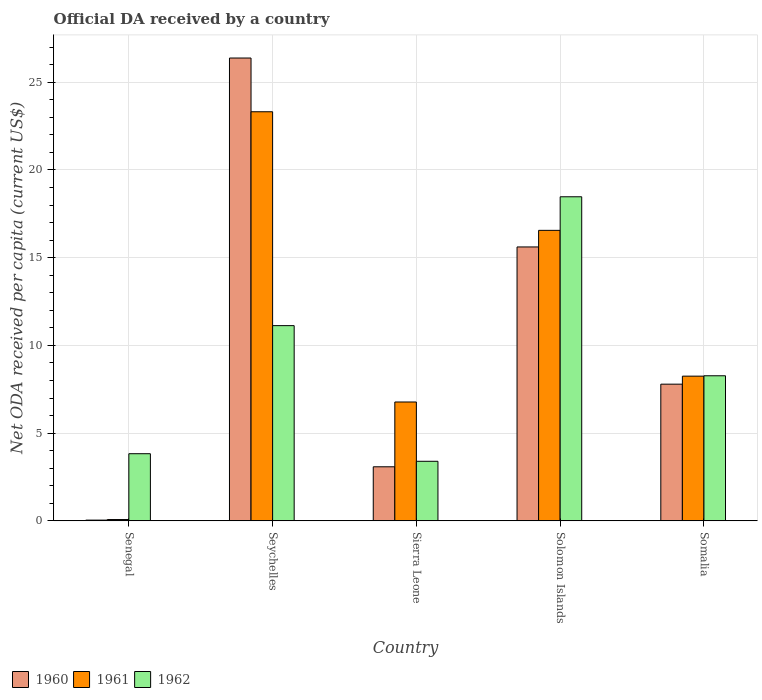What is the label of the 1st group of bars from the left?
Your answer should be very brief. Senegal. In how many cases, is the number of bars for a given country not equal to the number of legend labels?
Keep it short and to the point. 0. What is the ODA received in in 1961 in Seychelles?
Your answer should be compact. 23.32. Across all countries, what is the maximum ODA received in in 1960?
Your answer should be compact. 26.38. Across all countries, what is the minimum ODA received in in 1960?
Offer a terse response. 0.04. In which country was the ODA received in in 1960 maximum?
Provide a succinct answer. Seychelles. In which country was the ODA received in in 1961 minimum?
Your response must be concise. Senegal. What is the total ODA received in in 1961 in the graph?
Offer a very short reply. 54.97. What is the difference between the ODA received in in 1962 in Solomon Islands and that in Somalia?
Provide a short and direct response. 10.2. What is the difference between the ODA received in in 1960 in Senegal and the ODA received in in 1962 in Solomon Islands?
Offer a very short reply. -18.43. What is the average ODA received in in 1962 per country?
Give a very brief answer. 9.02. What is the difference between the ODA received in of/in 1960 and ODA received in of/in 1961 in Solomon Islands?
Provide a short and direct response. -0.95. In how many countries, is the ODA received in in 1962 greater than 17 US$?
Keep it short and to the point. 1. What is the ratio of the ODA received in in 1960 in Senegal to that in Solomon Islands?
Your response must be concise. 0. Is the ODA received in in 1961 in Senegal less than that in Seychelles?
Provide a succinct answer. Yes. Is the difference between the ODA received in in 1960 in Sierra Leone and Somalia greater than the difference between the ODA received in in 1961 in Sierra Leone and Somalia?
Provide a succinct answer. No. What is the difference between the highest and the second highest ODA received in in 1961?
Give a very brief answer. 8.31. What is the difference between the highest and the lowest ODA received in in 1961?
Offer a terse response. 23.24. In how many countries, is the ODA received in in 1961 greater than the average ODA received in in 1961 taken over all countries?
Make the answer very short. 2. Is the sum of the ODA received in in 1960 in Seychelles and Somalia greater than the maximum ODA received in in 1962 across all countries?
Provide a short and direct response. Yes. What does the 1st bar from the left in Senegal represents?
Offer a very short reply. 1960. What does the 2nd bar from the right in Seychelles represents?
Provide a short and direct response. 1961. Is it the case that in every country, the sum of the ODA received in in 1962 and ODA received in in 1960 is greater than the ODA received in in 1961?
Keep it short and to the point. No. How many bars are there?
Your answer should be compact. 15. Are all the bars in the graph horizontal?
Make the answer very short. No. Are the values on the major ticks of Y-axis written in scientific E-notation?
Your answer should be compact. No. Does the graph contain any zero values?
Provide a short and direct response. No. Where does the legend appear in the graph?
Offer a terse response. Bottom left. What is the title of the graph?
Make the answer very short. Official DA received by a country. What is the label or title of the Y-axis?
Your answer should be compact. Net ODA received per capita (current US$). What is the Net ODA received per capita (current US$) in 1960 in Senegal?
Offer a terse response. 0.04. What is the Net ODA received per capita (current US$) of 1961 in Senegal?
Provide a short and direct response. 0.07. What is the Net ODA received per capita (current US$) of 1962 in Senegal?
Your answer should be very brief. 3.83. What is the Net ODA received per capita (current US$) of 1960 in Seychelles?
Your answer should be very brief. 26.38. What is the Net ODA received per capita (current US$) in 1961 in Seychelles?
Provide a short and direct response. 23.32. What is the Net ODA received per capita (current US$) of 1962 in Seychelles?
Your answer should be compact. 11.13. What is the Net ODA received per capita (current US$) of 1960 in Sierra Leone?
Offer a terse response. 3.08. What is the Net ODA received per capita (current US$) in 1961 in Sierra Leone?
Ensure brevity in your answer.  6.77. What is the Net ODA received per capita (current US$) of 1962 in Sierra Leone?
Your answer should be very brief. 3.39. What is the Net ODA received per capita (current US$) in 1960 in Solomon Islands?
Make the answer very short. 15.61. What is the Net ODA received per capita (current US$) in 1961 in Solomon Islands?
Your answer should be compact. 16.56. What is the Net ODA received per capita (current US$) in 1962 in Solomon Islands?
Your answer should be very brief. 18.47. What is the Net ODA received per capita (current US$) in 1960 in Somalia?
Your response must be concise. 7.79. What is the Net ODA received per capita (current US$) of 1961 in Somalia?
Offer a very short reply. 8.25. What is the Net ODA received per capita (current US$) in 1962 in Somalia?
Provide a short and direct response. 8.27. Across all countries, what is the maximum Net ODA received per capita (current US$) in 1960?
Ensure brevity in your answer.  26.38. Across all countries, what is the maximum Net ODA received per capita (current US$) of 1961?
Provide a succinct answer. 23.32. Across all countries, what is the maximum Net ODA received per capita (current US$) in 1962?
Give a very brief answer. 18.47. Across all countries, what is the minimum Net ODA received per capita (current US$) in 1960?
Keep it short and to the point. 0.04. Across all countries, what is the minimum Net ODA received per capita (current US$) of 1961?
Your answer should be compact. 0.07. Across all countries, what is the minimum Net ODA received per capita (current US$) in 1962?
Your answer should be compact. 3.39. What is the total Net ODA received per capita (current US$) in 1960 in the graph?
Offer a very short reply. 52.9. What is the total Net ODA received per capita (current US$) in 1961 in the graph?
Provide a succinct answer. 54.97. What is the total Net ODA received per capita (current US$) of 1962 in the graph?
Offer a very short reply. 45.08. What is the difference between the Net ODA received per capita (current US$) in 1960 in Senegal and that in Seychelles?
Keep it short and to the point. -26.34. What is the difference between the Net ODA received per capita (current US$) of 1961 in Senegal and that in Seychelles?
Give a very brief answer. -23.24. What is the difference between the Net ODA received per capita (current US$) of 1962 in Senegal and that in Seychelles?
Give a very brief answer. -7.3. What is the difference between the Net ODA received per capita (current US$) of 1960 in Senegal and that in Sierra Leone?
Your response must be concise. -3.04. What is the difference between the Net ODA received per capita (current US$) in 1961 in Senegal and that in Sierra Leone?
Make the answer very short. -6.7. What is the difference between the Net ODA received per capita (current US$) of 1962 in Senegal and that in Sierra Leone?
Your response must be concise. 0.43. What is the difference between the Net ODA received per capita (current US$) in 1960 in Senegal and that in Solomon Islands?
Offer a terse response. -15.57. What is the difference between the Net ODA received per capita (current US$) in 1961 in Senegal and that in Solomon Islands?
Your answer should be compact. -16.48. What is the difference between the Net ODA received per capita (current US$) of 1962 in Senegal and that in Solomon Islands?
Your response must be concise. -14.64. What is the difference between the Net ODA received per capita (current US$) of 1960 in Senegal and that in Somalia?
Ensure brevity in your answer.  -7.75. What is the difference between the Net ODA received per capita (current US$) in 1961 in Senegal and that in Somalia?
Provide a succinct answer. -8.17. What is the difference between the Net ODA received per capita (current US$) of 1962 in Senegal and that in Somalia?
Provide a succinct answer. -4.44. What is the difference between the Net ODA received per capita (current US$) in 1960 in Seychelles and that in Sierra Leone?
Offer a terse response. 23.3. What is the difference between the Net ODA received per capita (current US$) of 1961 in Seychelles and that in Sierra Leone?
Offer a very short reply. 16.54. What is the difference between the Net ODA received per capita (current US$) in 1962 in Seychelles and that in Sierra Leone?
Provide a succinct answer. 7.73. What is the difference between the Net ODA received per capita (current US$) of 1960 in Seychelles and that in Solomon Islands?
Provide a short and direct response. 10.77. What is the difference between the Net ODA received per capita (current US$) in 1961 in Seychelles and that in Solomon Islands?
Your answer should be very brief. 6.76. What is the difference between the Net ODA received per capita (current US$) in 1962 in Seychelles and that in Solomon Islands?
Give a very brief answer. -7.34. What is the difference between the Net ODA received per capita (current US$) of 1960 in Seychelles and that in Somalia?
Provide a short and direct response. 18.59. What is the difference between the Net ODA received per capita (current US$) in 1961 in Seychelles and that in Somalia?
Keep it short and to the point. 15.07. What is the difference between the Net ODA received per capita (current US$) of 1962 in Seychelles and that in Somalia?
Your answer should be very brief. 2.86. What is the difference between the Net ODA received per capita (current US$) in 1960 in Sierra Leone and that in Solomon Islands?
Offer a very short reply. -12.53. What is the difference between the Net ODA received per capita (current US$) of 1961 in Sierra Leone and that in Solomon Islands?
Make the answer very short. -9.78. What is the difference between the Net ODA received per capita (current US$) of 1962 in Sierra Leone and that in Solomon Islands?
Your answer should be compact. -15.08. What is the difference between the Net ODA received per capita (current US$) in 1960 in Sierra Leone and that in Somalia?
Offer a very short reply. -4.71. What is the difference between the Net ODA received per capita (current US$) of 1961 in Sierra Leone and that in Somalia?
Offer a terse response. -1.47. What is the difference between the Net ODA received per capita (current US$) in 1962 in Sierra Leone and that in Somalia?
Give a very brief answer. -4.87. What is the difference between the Net ODA received per capita (current US$) of 1960 in Solomon Islands and that in Somalia?
Give a very brief answer. 7.82. What is the difference between the Net ODA received per capita (current US$) of 1961 in Solomon Islands and that in Somalia?
Ensure brevity in your answer.  8.31. What is the difference between the Net ODA received per capita (current US$) of 1962 in Solomon Islands and that in Somalia?
Your response must be concise. 10.2. What is the difference between the Net ODA received per capita (current US$) in 1960 in Senegal and the Net ODA received per capita (current US$) in 1961 in Seychelles?
Keep it short and to the point. -23.28. What is the difference between the Net ODA received per capita (current US$) in 1960 in Senegal and the Net ODA received per capita (current US$) in 1962 in Seychelles?
Provide a short and direct response. -11.08. What is the difference between the Net ODA received per capita (current US$) of 1961 in Senegal and the Net ODA received per capita (current US$) of 1962 in Seychelles?
Make the answer very short. -11.05. What is the difference between the Net ODA received per capita (current US$) in 1960 in Senegal and the Net ODA received per capita (current US$) in 1961 in Sierra Leone?
Provide a succinct answer. -6.73. What is the difference between the Net ODA received per capita (current US$) in 1960 in Senegal and the Net ODA received per capita (current US$) in 1962 in Sierra Leone?
Your answer should be compact. -3.35. What is the difference between the Net ODA received per capita (current US$) in 1961 in Senegal and the Net ODA received per capita (current US$) in 1962 in Sierra Leone?
Provide a short and direct response. -3.32. What is the difference between the Net ODA received per capita (current US$) in 1960 in Senegal and the Net ODA received per capita (current US$) in 1961 in Solomon Islands?
Provide a short and direct response. -16.52. What is the difference between the Net ODA received per capita (current US$) in 1960 in Senegal and the Net ODA received per capita (current US$) in 1962 in Solomon Islands?
Ensure brevity in your answer.  -18.43. What is the difference between the Net ODA received per capita (current US$) of 1961 in Senegal and the Net ODA received per capita (current US$) of 1962 in Solomon Islands?
Offer a terse response. -18.4. What is the difference between the Net ODA received per capita (current US$) of 1960 in Senegal and the Net ODA received per capita (current US$) of 1961 in Somalia?
Make the answer very short. -8.21. What is the difference between the Net ODA received per capita (current US$) of 1960 in Senegal and the Net ODA received per capita (current US$) of 1962 in Somalia?
Give a very brief answer. -8.23. What is the difference between the Net ODA received per capita (current US$) of 1961 in Senegal and the Net ODA received per capita (current US$) of 1962 in Somalia?
Make the answer very short. -8.19. What is the difference between the Net ODA received per capita (current US$) in 1960 in Seychelles and the Net ODA received per capita (current US$) in 1961 in Sierra Leone?
Keep it short and to the point. 19.61. What is the difference between the Net ODA received per capita (current US$) in 1960 in Seychelles and the Net ODA received per capita (current US$) in 1962 in Sierra Leone?
Your answer should be compact. 22.99. What is the difference between the Net ODA received per capita (current US$) in 1961 in Seychelles and the Net ODA received per capita (current US$) in 1962 in Sierra Leone?
Provide a short and direct response. 19.92. What is the difference between the Net ODA received per capita (current US$) of 1960 in Seychelles and the Net ODA received per capita (current US$) of 1961 in Solomon Islands?
Offer a terse response. 9.82. What is the difference between the Net ODA received per capita (current US$) of 1960 in Seychelles and the Net ODA received per capita (current US$) of 1962 in Solomon Islands?
Give a very brief answer. 7.91. What is the difference between the Net ODA received per capita (current US$) of 1961 in Seychelles and the Net ODA received per capita (current US$) of 1962 in Solomon Islands?
Make the answer very short. 4.85. What is the difference between the Net ODA received per capita (current US$) of 1960 in Seychelles and the Net ODA received per capita (current US$) of 1961 in Somalia?
Your answer should be compact. 18.13. What is the difference between the Net ODA received per capita (current US$) of 1960 in Seychelles and the Net ODA received per capita (current US$) of 1962 in Somalia?
Your answer should be compact. 18.11. What is the difference between the Net ODA received per capita (current US$) of 1961 in Seychelles and the Net ODA received per capita (current US$) of 1962 in Somalia?
Your answer should be very brief. 15.05. What is the difference between the Net ODA received per capita (current US$) of 1960 in Sierra Leone and the Net ODA received per capita (current US$) of 1961 in Solomon Islands?
Offer a very short reply. -13.48. What is the difference between the Net ODA received per capita (current US$) in 1960 in Sierra Leone and the Net ODA received per capita (current US$) in 1962 in Solomon Islands?
Ensure brevity in your answer.  -15.39. What is the difference between the Net ODA received per capita (current US$) of 1961 in Sierra Leone and the Net ODA received per capita (current US$) of 1962 in Solomon Islands?
Your answer should be very brief. -11.7. What is the difference between the Net ODA received per capita (current US$) of 1960 in Sierra Leone and the Net ODA received per capita (current US$) of 1961 in Somalia?
Offer a very short reply. -5.17. What is the difference between the Net ODA received per capita (current US$) in 1960 in Sierra Leone and the Net ODA received per capita (current US$) in 1962 in Somalia?
Give a very brief answer. -5.19. What is the difference between the Net ODA received per capita (current US$) in 1961 in Sierra Leone and the Net ODA received per capita (current US$) in 1962 in Somalia?
Offer a very short reply. -1.49. What is the difference between the Net ODA received per capita (current US$) in 1960 in Solomon Islands and the Net ODA received per capita (current US$) in 1961 in Somalia?
Ensure brevity in your answer.  7.36. What is the difference between the Net ODA received per capita (current US$) in 1960 in Solomon Islands and the Net ODA received per capita (current US$) in 1962 in Somalia?
Keep it short and to the point. 7.34. What is the difference between the Net ODA received per capita (current US$) of 1961 in Solomon Islands and the Net ODA received per capita (current US$) of 1962 in Somalia?
Offer a very short reply. 8.29. What is the average Net ODA received per capita (current US$) in 1960 per country?
Provide a succinct answer. 10.58. What is the average Net ODA received per capita (current US$) in 1961 per country?
Your answer should be compact. 10.99. What is the average Net ODA received per capita (current US$) in 1962 per country?
Your response must be concise. 9.02. What is the difference between the Net ODA received per capita (current US$) in 1960 and Net ODA received per capita (current US$) in 1961 in Senegal?
Make the answer very short. -0.03. What is the difference between the Net ODA received per capita (current US$) of 1960 and Net ODA received per capita (current US$) of 1962 in Senegal?
Offer a terse response. -3.78. What is the difference between the Net ODA received per capita (current US$) in 1961 and Net ODA received per capita (current US$) in 1962 in Senegal?
Your answer should be compact. -3.75. What is the difference between the Net ODA received per capita (current US$) of 1960 and Net ODA received per capita (current US$) of 1961 in Seychelles?
Provide a succinct answer. 3.06. What is the difference between the Net ODA received per capita (current US$) in 1960 and Net ODA received per capita (current US$) in 1962 in Seychelles?
Your response must be concise. 15.25. What is the difference between the Net ODA received per capita (current US$) in 1961 and Net ODA received per capita (current US$) in 1962 in Seychelles?
Provide a succinct answer. 12.19. What is the difference between the Net ODA received per capita (current US$) in 1960 and Net ODA received per capita (current US$) in 1961 in Sierra Leone?
Your response must be concise. -3.69. What is the difference between the Net ODA received per capita (current US$) of 1960 and Net ODA received per capita (current US$) of 1962 in Sierra Leone?
Provide a succinct answer. -0.31. What is the difference between the Net ODA received per capita (current US$) in 1961 and Net ODA received per capita (current US$) in 1962 in Sierra Leone?
Your response must be concise. 3.38. What is the difference between the Net ODA received per capita (current US$) of 1960 and Net ODA received per capita (current US$) of 1961 in Solomon Islands?
Your answer should be compact. -0.95. What is the difference between the Net ODA received per capita (current US$) of 1960 and Net ODA received per capita (current US$) of 1962 in Solomon Islands?
Give a very brief answer. -2.86. What is the difference between the Net ODA received per capita (current US$) of 1961 and Net ODA received per capita (current US$) of 1962 in Solomon Islands?
Your answer should be very brief. -1.91. What is the difference between the Net ODA received per capita (current US$) in 1960 and Net ODA received per capita (current US$) in 1961 in Somalia?
Ensure brevity in your answer.  -0.46. What is the difference between the Net ODA received per capita (current US$) of 1960 and Net ODA received per capita (current US$) of 1962 in Somalia?
Your answer should be compact. -0.48. What is the difference between the Net ODA received per capita (current US$) of 1961 and Net ODA received per capita (current US$) of 1962 in Somalia?
Provide a succinct answer. -0.02. What is the ratio of the Net ODA received per capita (current US$) of 1960 in Senegal to that in Seychelles?
Offer a very short reply. 0. What is the ratio of the Net ODA received per capita (current US$) of 1961 in Senegal to that in Seychelles?
Keep it short and to the point. 0. What is the ratio of the Net ODA received per capita (current US$) of 1962 in Senegal to that in Seychelles?
Offer a very short reply. 0.34. What is the ratio of the Net ODA received per capita (current US$) of 1960 in Senegal to that in Sierra Leone?
Ensure brevity in your answer.  0.01. What is the ratio of the Net ODA received per capita (current US$) in 1961 in Senegal to that in Sierra Leone?
Provide a short and direct response. 0.01. What is the ratio of the Net ODA received per capita (current US$) of 1962 in Senegal to that in Sierra Leone?
Your response must be concise. 1.13. What is the ratio of the Net ODA received per capita (current US$) in 1960 in Senegal to that in Solomon Islands?
Your answer should be very brief. 0. What is the ratio of the Net ODA received per capita (current US$) of 1961 in Senegal to that in Solomon Islands?
Offer a terse response. 0. What is the ratio of the Net ODA received per capita (current US$) in 1962 in Senegal to that in Solomon Islands?
Offer a very short reply. 0.21. What is the ratio of the Net ODA received per capita (current US$) in 1960 in Senegal to that in Somalia?
Provide a short and direct response. 0.01. What is the ratio of the Net ODA received per capita (current US$) in 1961 in Senegal to that in Somalia?
Provide a short and direct response. 0.01. What is the ratio of the Net ODA received per capita (current US$) in 1962 in Senegal to that in Somalia?
Your response must be concise. 0.46. What is the ratio of the Net ODA received per capita (current US$) in 1960 in Seychelles to that in Sierra Leone?
Your answer should be compact. 8.56. What is the ratio of the Net ODA received per capita (current US$) in 1961 in Seychelles to that in Sierra Leone?
Make the answer very short. 3.44. What is the ratio of the Net ODA received per capita (current US$) in 1962 in Seychelles to that in Sierra Leone?
Provide a succinct answer. 3.28. What is the ratio of the Net ODA received per capita (current US$) in 1960 in Seychelles to that in Solomon Islands?
Ensure brevity in your answer.  1.69. What is the ratio of the Net ODA received per capita (current US$) of 1961 in Seychelles to that in Solomon Islands?
Your answer should be very brief. 1.41. What is the ratio of the Net ODA received per capita (current US$) of 1962 in Seychelles to that in Solomon Islands?
Make the answer very short. 0.6. What is the ratio of the Net ODA received per capita (current US$) in 1960 in Seychelles to that in Somalia?
Your response must be concise. 3.39. What is the ratio of the Net ODA received per capita (current US$) of 1961 in Seychelles to that in Somalia?
Give a very brief answer. 2.83. What is the ratio of the Net ODA received per capita (current US$) of 1962 in Seychelles to that in Somalia?
Give a very brief answer. 1.35. What is the ratio of the Net ODA received per capita (current US$) of 1960 in Sierra Leone to that in Solomon Islands?
Provide a short and direct response. 0.2. What is the ratio of the Net ODA received per capita (current US$) in 1961 in Sierra Leone to that in Solomon Islands?
Offer a terse response. 0.41. What is the ratio of the Net ODA received per capita (current US$) in 1962 in Sierra Leone to that in Solomon Islands?
Your response must be concise. 0.18. What is the ratio of the Net ODA received per capita (current US$) in 1960 in Sierra Leone to that in Somalia?
Give a very brief answer. 0.4. What is the ratio of the Net ODA received per capita (current US$) in 1961 in Sierra Leone to that in Somalia?
Your answer should be compact. 0.82. What is the ratio of the Net ODA received per capita (current US$) in 1962 in Sierra Leone to that in Somalia?
Make the answer very short. 0.41. What is the ratio of the Net ODA received per capita (current US$) in 1960 in Solomon Islands to that in Somalia?
Provide a short and direct response. 2. What is the ratio of the Net ODA received per capita (current US$) in 1961 in Solomon Islands to that in Somalia?
Your answer should be compact. 2.01. What is the ratio of the Net ODA received per capita (current US$) in 1962 in Solomon Islands to that in Somalia?
Keep it short and to the point. 2.23. What is the difference between the highest and the second highest Net ODA received per capita (current US$) in 1960?
Offer a very short reply. 10.77. What is the difference between the highest and the second highest Net ODA received per capita (current US$) in 1961?
Give a very brief answer. 6.76. What is the difference between the highest and the second highest Net ODA received per capita (current US$) in 1962?
Ensure brevity in your answer.  7.34. What is the difference between the highest and the lowest Net ODA received per capita (current US$) of 1960?
Your answer should be compact. 26.34. What is the difference between the highest and the lowest Net ODA received per capita (current US$) of 1961?
Make the answer very short. 23.24. What is the difference between the highest and the lowest Net ODA received per capita (current US$) in 1962?
Offer a terse response. 15.08. 